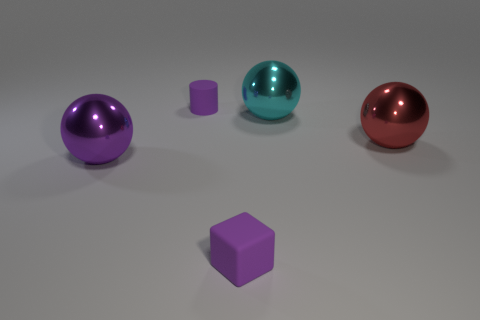There is a rubber thing that is the same color as the small cylinder; what size is it?
Your answer should be compact. Small. How many other objects are the same shape as the cyan object?
Provide a succinct answer. 2. There is a object to the right of the cyan ball; how big is it?
Your response must be concise. Large. What number of tiny blocks are behind the small purple thing that is behind the cyan metallic ball?
Offer a terse response. 0. How many other objects are there of the same size as the purple rubber cylinder?
Make the answer very short. 1. Does the rubber cube have the same color as the tiny matte cylinder?
Provide a succinct answer. Yes. Is the shape of the small object in front of the small purple rubber cylinder the same as  the cyan metal thing?
Provide a succinct answer. No. What number of large balls are left of the tiny purple cylinder and right of the big cyan object?
Ensure brevity in your answer.  0. What is the cylinder made of?
Give a very brief answer. Rubber. Are the cyan ball and the cylinder made of the same material?
Provide a short and direct response. No. 